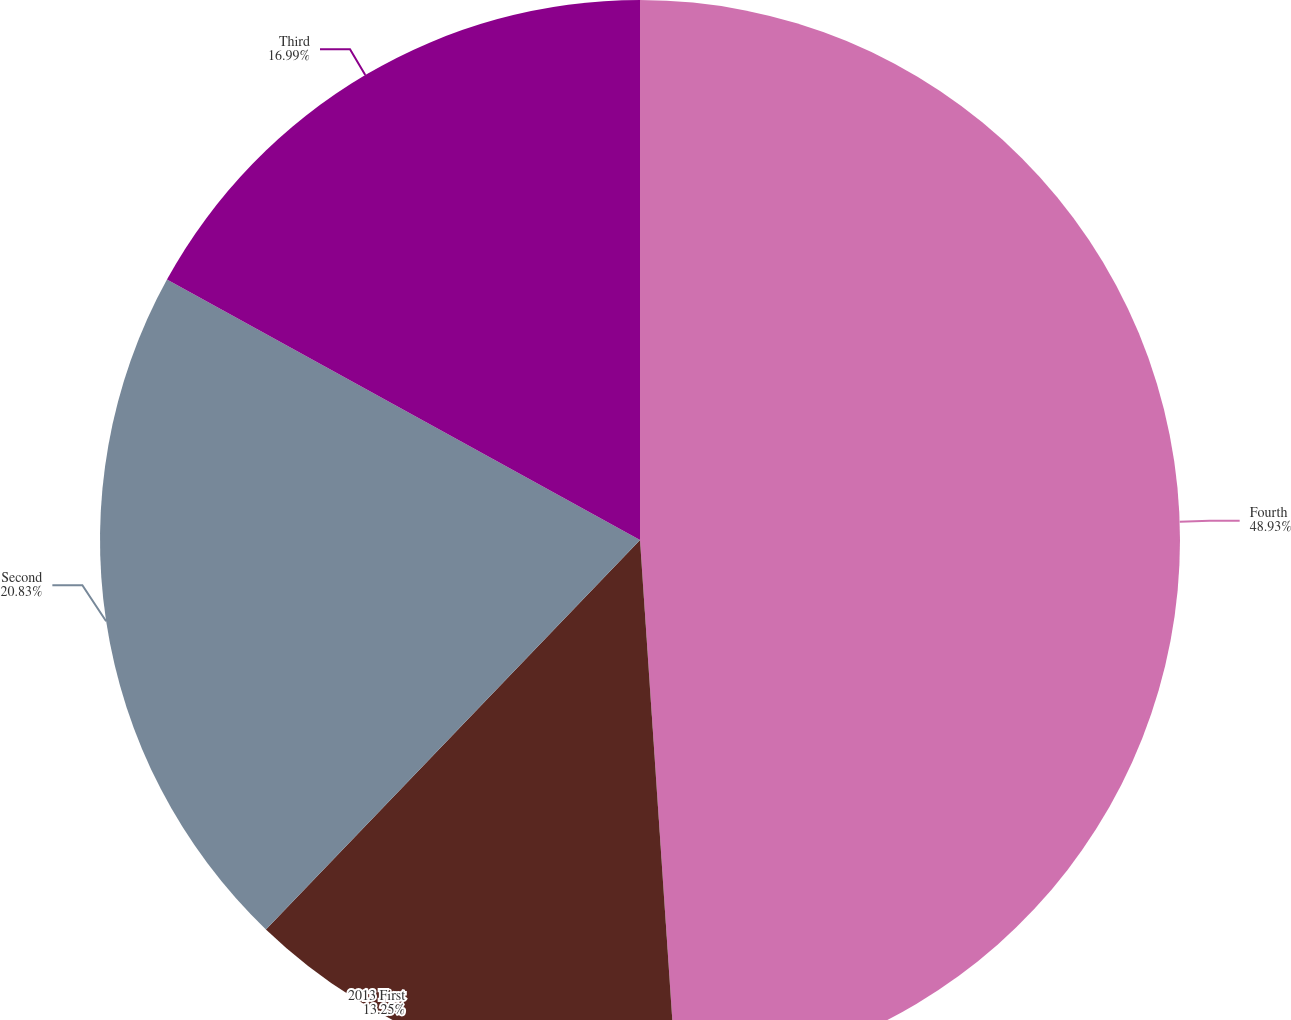Convert chart to OTSL. <chart><loc_0><loc_0><loc_500><loc_500><pie_chart><fcel>Fourth<fcel>2013 First<fcel>Second<fcel>Third<nl><fcel>48.93%<fcel>13.25%<fcel>20.83%<fcel>16.99%<nl></chart> 